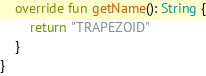<code> <loc_0><loc_0><loc_500><loc_500><_Kotlin_>
    override fun getName(): String {
        return "TRAPEZOID"
    }
}
</code> 